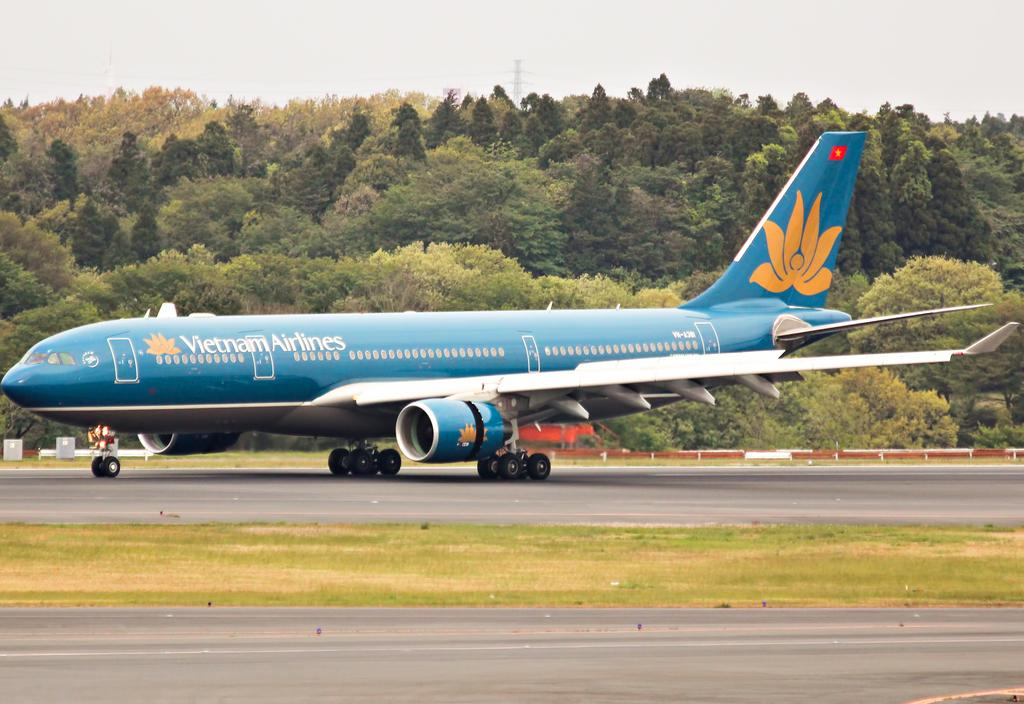<image>
Describe the image concisely. A blue and yellow air plane with the vietnam airlines logo on its side. 